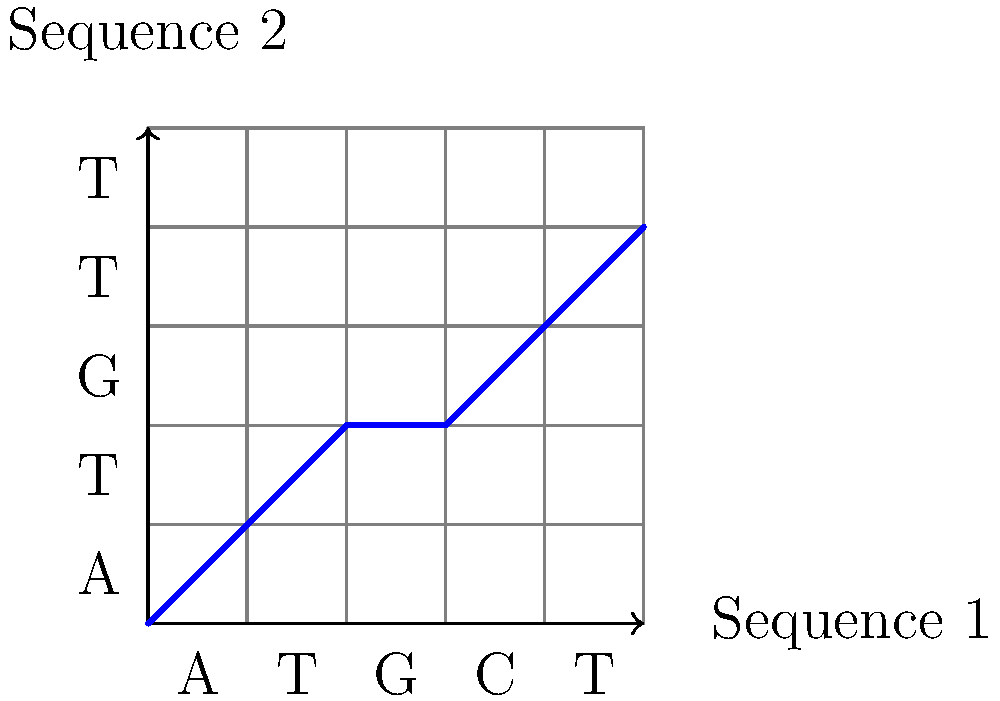In the 2D grid coordinate system representing a DNA sequence alignment, what does the blue line indicate about the relationship between the two sequences, and how would you describe the alignment at position (3,2)? To understand this DNA sequence alignment representation:

1. The x-axis represents Sequence 1 (ATGCT), and the y-axis represents Sequence 2 (ATGTT).

2. The blue line shows the alignment path between the two sequences:
   - Diagonal movements indicate matches between nucleotides.
   - Horizontal movements indicate gaps (insertions) in Sequence 2.
   - Vertical movements indicate gaps (deletions) in Sequence 1.

3. Following the blue line from (0,0) to (5,4):
   - (0,0) to (2,2): Perfect match for the first three nucleotides (ATG)
   - (2,2) to (3,2): Horizontal movement, indicating a gap in Sequence 2
   - (3,2) to (5,4): Diagonal movement, indicating matches for the last two nucleotides (TT)

4. At position (3,2):
   - The nucleotide in Sequence 1 is C
   - The alignment shows a horizontal movement
   - This indicates that C in Sequence 1 is aligned with a gap in Sequence 2

Therefore, the blue line indicates the overall alignment pattern between the two sequences, showing matches, insertions, and deletions. At position (3,2), the alignment represents a gap in Sequence 2 aligned with C in Sequence 1.
Answer: Gap in Sequence 2 aligned with C in Sequence 1 